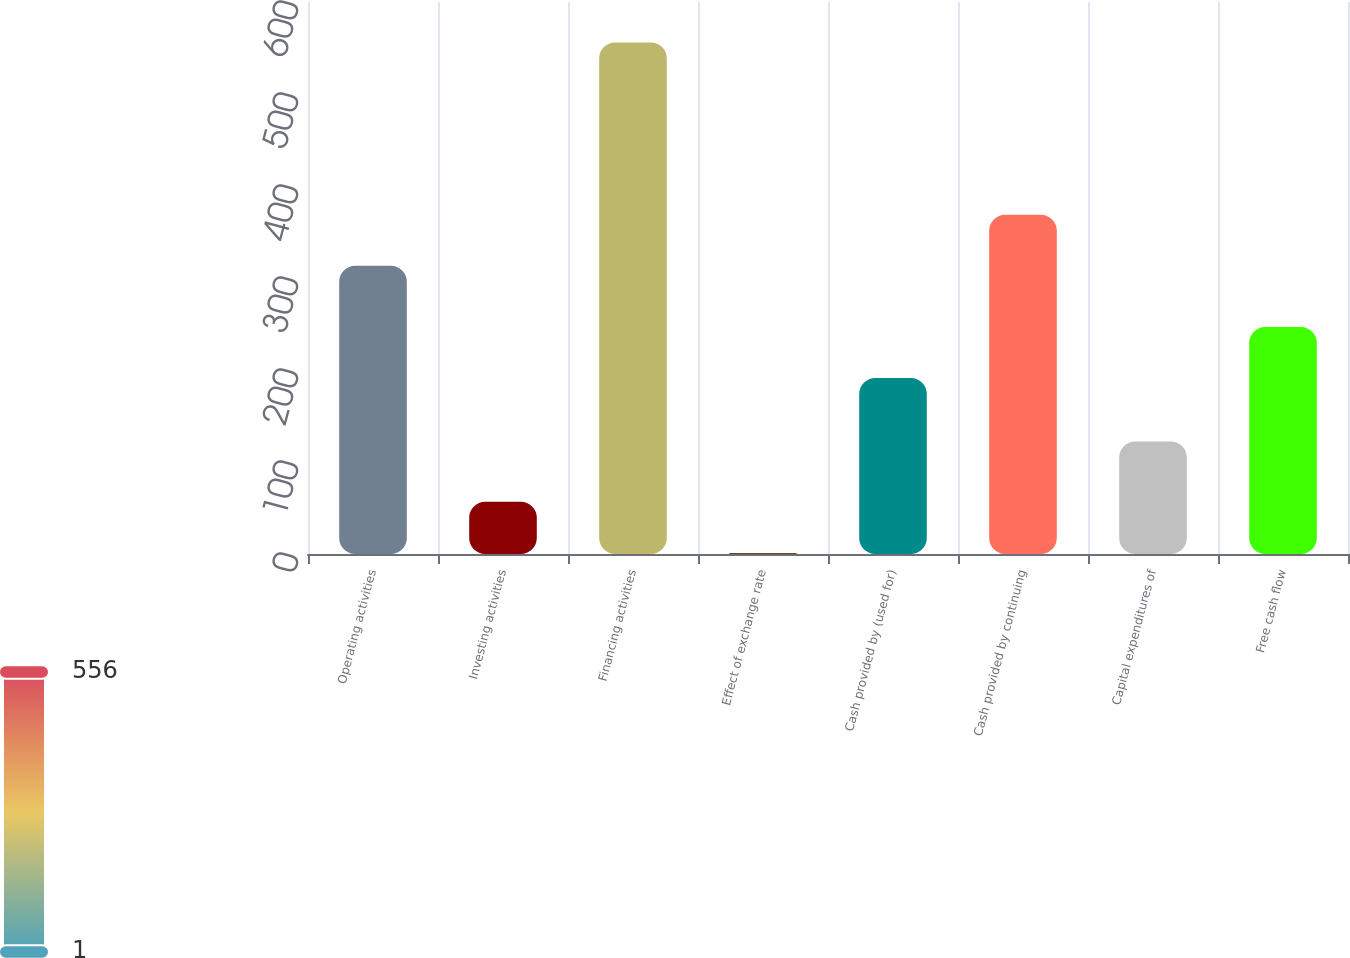<chart> <loc_0><loc_0><loc_500><loc_500><bar_chart><fcel>Operating activities<fcel>Investing activities<fcel>Financing activities<fcel>Effect of exchange rate<fcel>Cash provided by (used for)<fcel>Cash provided by continuing<fcel>Capital expenditures of<fcel>Free cash flow<nl><fcel>313.3<fcel>56.69<fcel>556.1<fcel>1.2<fcel>191.3<fcel>368.79<fcel>122.3<fcel>246.79<nl></chart> 